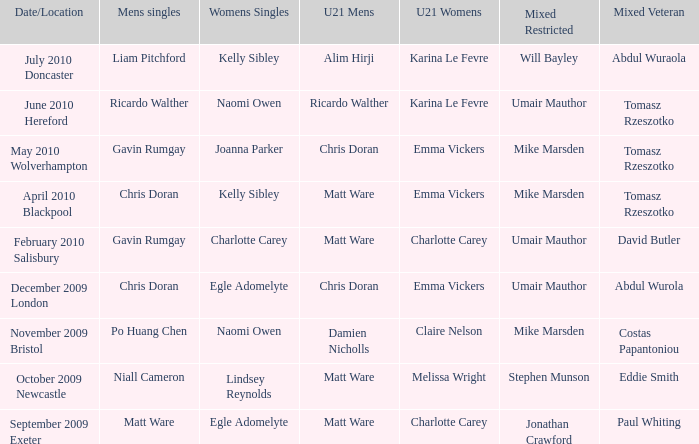When and where did Eddie Smith win the mixed veteran? 1.0. 